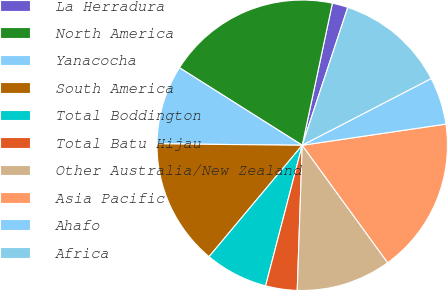<chart> <loc_0><loc_0><loc_500><loc_500><pie_chart><fcel>La Herradura<fcel>North America<fcel>Yanacocha<fcel>South America<fcel>Total Boddington<fcel>Total Batu Hijau<fcel>Other Australia/New Zealand<fcel>Asia Pacific<fcel>Ahafo<fcel>Africa<nl><fcel>1.75%<fcel>19.37%<fcel>8.8%<fcel>14.08%<fcel>7.03%<fcel>3.51%<fcel>10.56%<fcel>17.32%<fcel>5.27%<fcel>12.32%<nl></chart> 